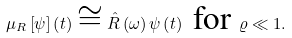Convert formula to latex. <formula><loc_0><loc_0><loc_500><loc_500>\mu _ { R } \left [ \psi \right ] \left ( t \right ) \cong \hat { R } \left ( \omega \right ) \psi \left ( t \right ) \text { for } \varrho \ll 1 .</formula> 